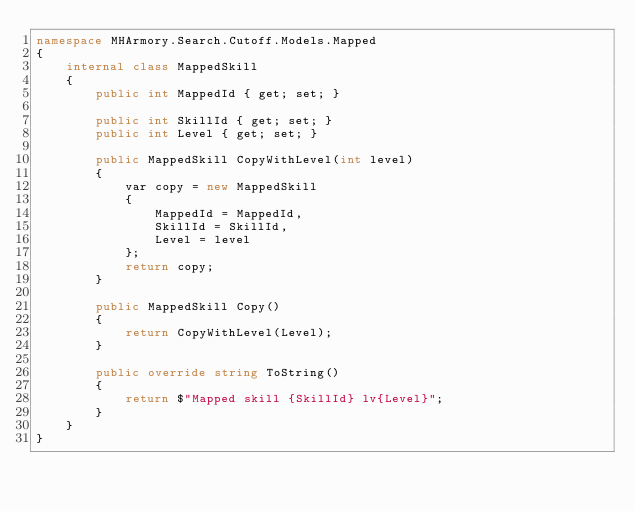Convert code to text. <code><loc_0><loc_0><loc_500><loc_500><_C#_>namespace MHArmory.Search.Cutoff.Models.Mapped
{
    internal class MappedSkill
    {
        public int MappedId { get; set; }

        public int SkillId { get; set; }
        public int Level { get; set; }

        public MappedSkill CopyWithLevel(int level)
        {
            var copy = new MappedSkill
            {
                MappedId = MappedId,
                SkillId = SkillId,
                Level = level
            };
            return copy;
        }

        public MappedSkill Copy()
        {
            return CopyWithLevel(Level);
        }

        public override string ToString()
        {
            return $"Mapped skill {SkillId} lv{Level}";
        }
    }
}
</code> 